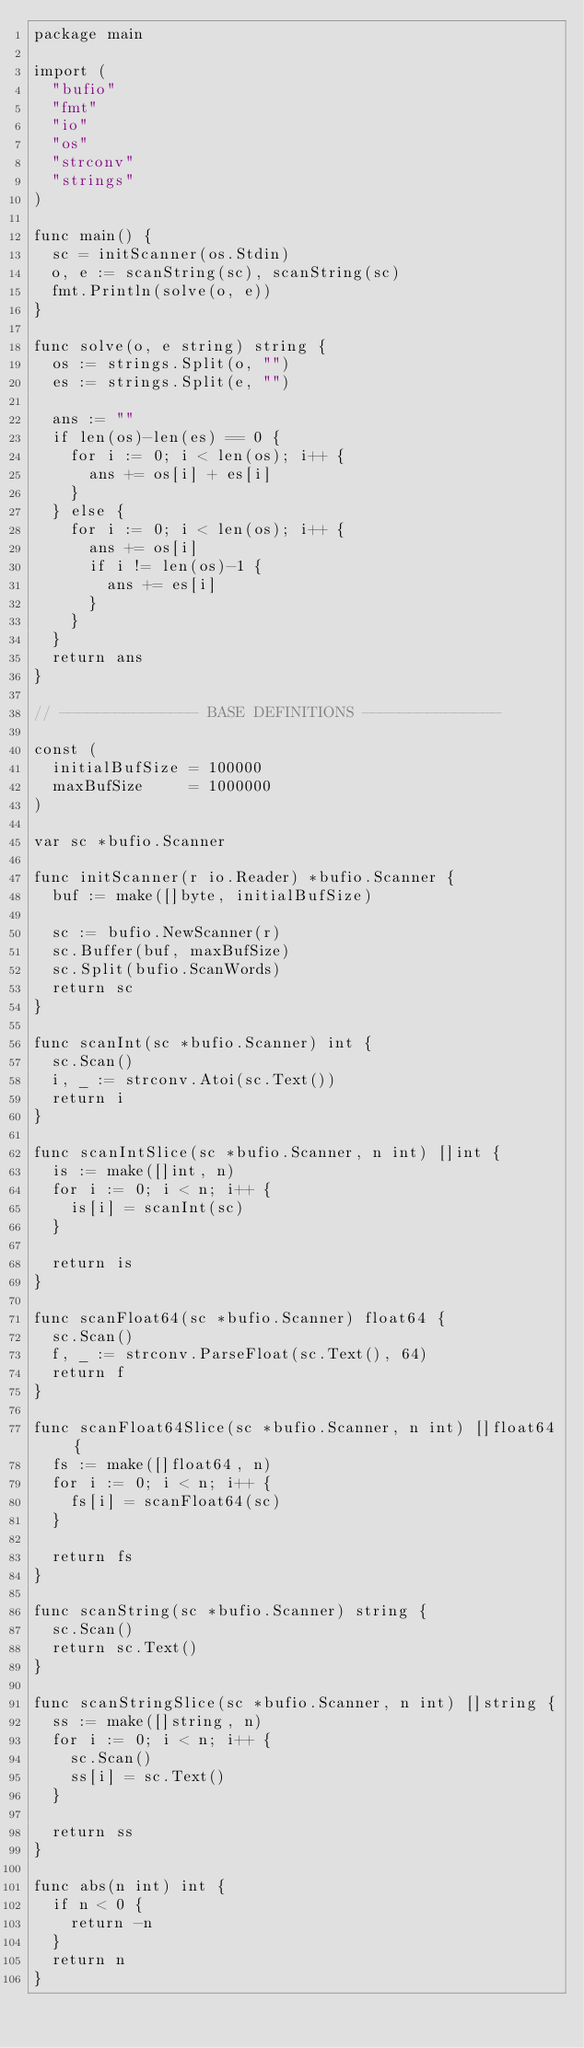<code> <loc_0><loc_0><loc_500><loc_500><_Go_>package main

import (
	"bufio"
	"fmt"
	"io"
	"os"
	"strconv"
	"strings"
)

func main() {
	sc = initScanner(os.Stdin)
	o, e := scanString(sc), scanString(sc)
	fmt.Println(solve(o, e))
}

func solve(o, e string) string {
	os := strings.Split(o, "")
	es := strings.Split(e, "")

	ans := ""
	if len(os)-len(es) == 0 {
		for i := 0; i < len(os); i++ {
			ans += os[i] + es[i]
		}
	} else {
		for i := 0; i < len(os); i++ {
			ans += os[i]
			if i != len(os)-1 {
				ans += es[i]
			}
		}
	}
	return ans
}

// --------------- BASE DEFINITIONS ---------------

const (
	initialBufSize = 100000
	maxBufSize     = 1000000
)

var sc *bufio.Scanner

func initScanner(r io.Reader) *bufio.Scanner {
	buf := make([]byte, initialBufSize)

	sc := bufio.NewScanner(r)
	sc.Buffer(buf, maxBufSize)
	sc.Split(bufio.ScanWords)
	return sc
}

func scanInt(sc *bufio.Scanner) int {
	sc.Scan()
	i, _ := strconv.Atoi(sc.Text())
	return i
}

func scanIntSlice(sc *bufio.Scanner, n int) []int {
	is := make([]int, n)
	for i := 0; i < n; i++ {
		is[i] = scanInt(sc)
	}

	return is
}

func scanFloat64(sc *bufio.Scanner) float64 {
	sc.Scan()
	f, _ := strconv.ParseFloat(sc.Text(), 64)
	return f
}

func scanFloat64Slice(sc *bufio.Scanner, n int) []float64 {
	fs := make([]float64, n)
	for i := 0; i < n; i++ {
		fs[i] = scanFloat64(sc)
	}

	return fs
}

func scanString(sc *bufio.Scanner) string {
	sc.Scan()
	return sc.Text()
}

func scanStringSlice(sc *bufio.Scanner, n int) []string {
	ss := make([]string, n)
	for i := 0; i < n; i++ {
		sc.Scan()
		ss[i] = sc.Text()
	}

	return ss
}

func abs(n int) int {
	if n < 0 {
		return -n
	}
	return n
}
</code> 